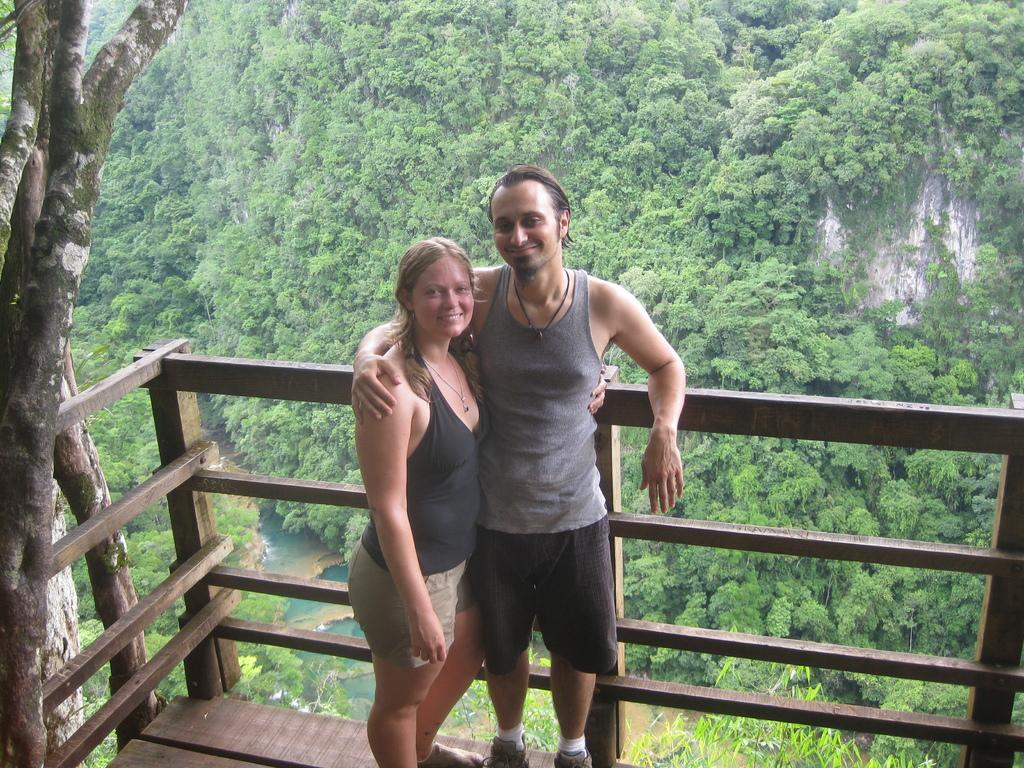How many people are present in the image? There are two people, a man and a woman, present in the image. What are the people in the image doing? Both the man and the woman are standing and smiling. What can be seen in the background of the image? There is wooden fencing, water, and trees visible in the image. What type of bucket can be seen in the hands of the police officer in the image? There is no police officer or bucket present in the image. What is the tendency of the people in the image to commit crimes? There is no information about the people's tendency to commit crimes in the image. 